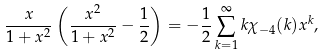Convert formula to latex. <formula><loc_0><loc_0><loc_500><loc_500>\frac { x } { 1 + x ^ { 2 } } \left ( \frac { x ^ { 2 } } { 1 + x ^ { 2 } } - \frac { 1 } { 2 } \right ) = - \frac { 1 } { 2 } \sum _ { k = 1 } ^ { \infty } k \chi _ { - 4 } ( k ) x ^ { k } ,</formula> 